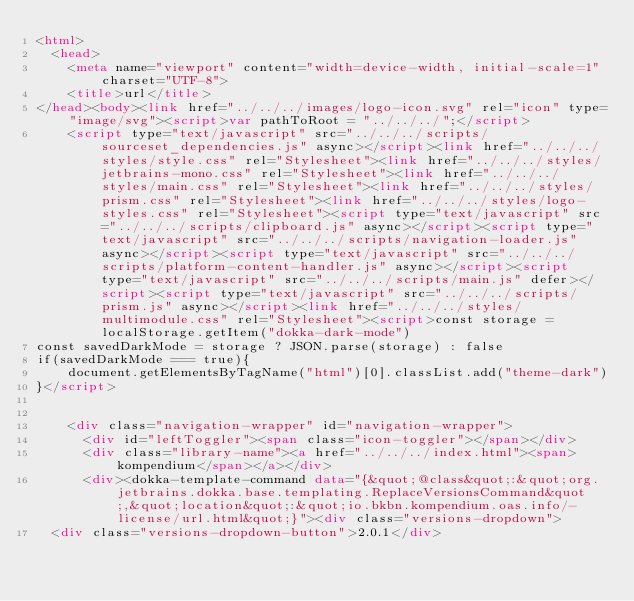Convert code to text. <code><loc_0><loc_0><loc_500><loc_500><_HTML_><html>
  <head>
    <meta name="viewport" content="width=device-width, initial-scale=1" charset="UTF-8">
    <title>url</title>
</head><body><link href="../../../images/logo-icon.svg" rel="icon" type="image/svg"><script>var pathToRoot = "../../../";</script>
    <script type="text/javascript" src="../../../scripts/sourceset_dependencies.js" async></script><link href="../../../styles/style.css" rel="Stylesheet"><link href="../../../styles/jetbrains-mono.css" rel="Stylesheet"><link href="../../../styles/main.css" rel="Stylesheet"><link href="../../../styles/prism.css" rel="Stylesheet"><link href="../../../styles/logo-styles.css" rel="Stylesheet"><script type="text/javascript" src="../../../scripts/clipboard.js" async></script><script type="text/javascript" src="../../../scripts/navigation-loader.js" async></script><script type="text/javascript" src="../../../scripts/platform-content-handler.js" async></script><script type="text/javascript" src="../../../scripts/main.js" defer></script><script type="text/javascript" src="../../../scripts/prism.js" async></script><link href="../../../styles/multimodule.css" rel="Stylesheet"><script>const storage = localStorage.getItem("dokka-dark-mode")
const savedDarkMode = storage ? JSON.parse(storage) : false
if(savedDarkMode === true){
    document.getElementsByTagName("html")[0].classList.add("theme-dark")
}</script>

  
    <div class="navigation-wrapper" id="navigation-wrapper">
      <div id="leftToggler"><span class="icon-toggler"></span></div>
      <div class="library-name"><a href="../../../index.html"><span>kompendium</span></a></div>
      <div><dokka-template-command data="{&quot;@class&quot;:&quot;org.jetbrains.dokka.base.templating.ReplaceVersionsCommand&quot;,&quot;location&quot;:&quot;io.bkbn.kompendium.oas.info/-license/url.html&quot;}"><div class="versions-dropdown">
  <div class="versions-dropdown-button">2.0.1</div></code> 